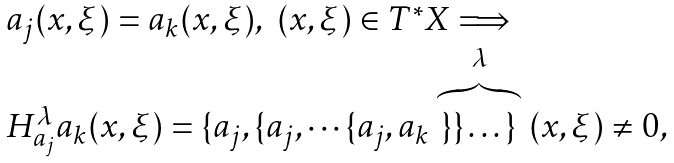Convert formula to latex. <formula><loc_0><loc_0><loc_500><loc_500>\begin{array} { l } a _ { j } ( x , \xi ) = a _ { k } ( x , \xi ) , \ ( x , \xi ) \in T ^ { * } X \Longrightarrow \\ H _ { a _ { j } } ^ { \lambda } a _ { k } ( x , \xi ) = \{ a _ { j } , \{ a _ { j } , \cdots \{ a _ { j } , a _ { k } \stackrel { \lambda } { \overbrace { \} \} \dots \} } } ( x , \xi ) \not = 0 , \end{array}</formula> 